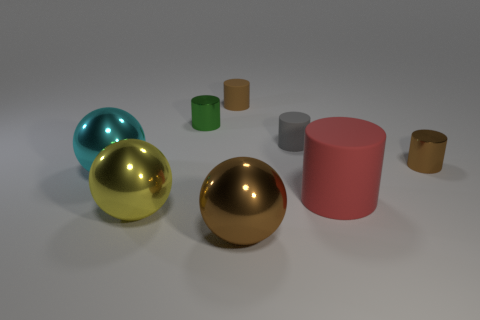What is the shape of the red rubber object that is the same size as the yellow metal ball?
Make the answer very short. Cylinder. Are there any tiny brown objects behind the green metallic object?
Keep it short and to the point. Yes. Is the size of the gray object the same as the red matte thing?
Your answer should be compact. No. The tiny metal thing that is to the right of the tiny green cylinder has what shape?
Make the answer very short. Cylinder. Are there any brown metallic cylinders that have the same size as the gray cylinder?
Give a very brief answer. Yes. What is the material of the red object that is the same size as the yellow shiny thing?
Offer a terse response. Rubber. There is a metallic sphere to the left of the big yellow metal object; how big is it?
Offer a very short reply. Large. What size is the green metal object?
Give a very brief answer. Small. There is a red rubber cylinder; is it the same size as the yellow ball to the left of the large matte object?
Provide a short and direct response. Yes. The tiny thing left of the tiny rubber object that is to the left of the big brown sphere is what color?
Keep it short and to the point. Green. 